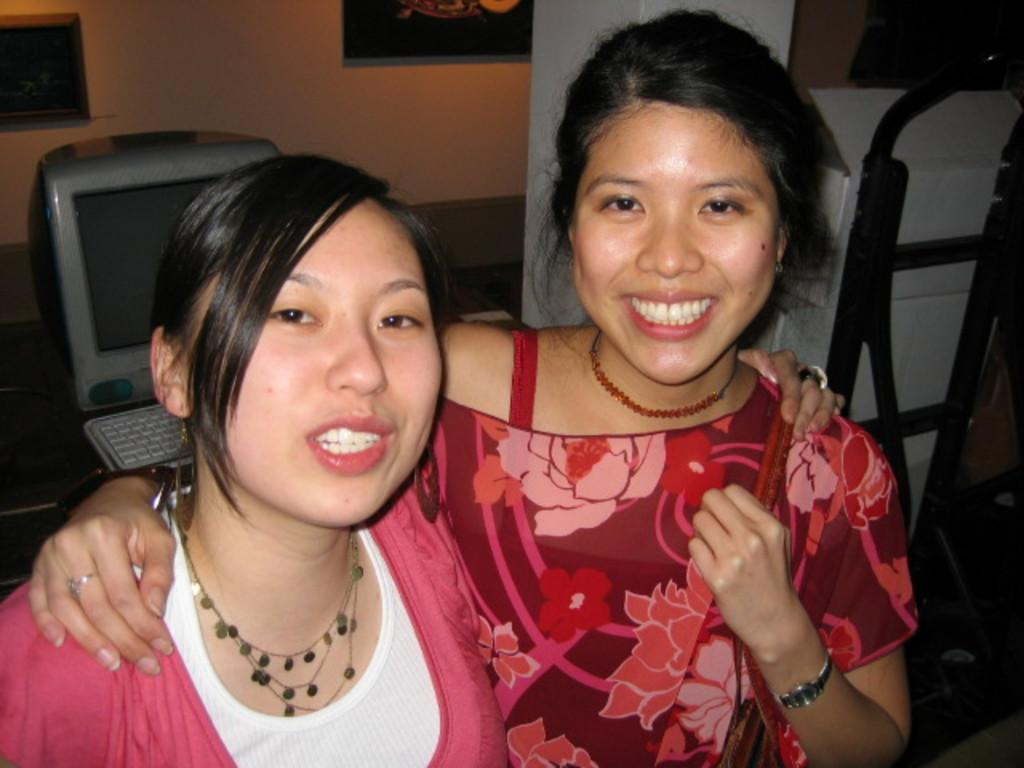How many ladies are in the image? There are two ladies in the image. What are the ladies doing in the image? The ladies are looking at something and smiling. What are the ladies wearing that is mentioned in the facts? The ladies are wearing chains. What can be seen in the background of the image? There is a wall, pillars, a monitor, a keyboard, and rods in the background of the image. What type of wax is being used by the ladies in the image? There is no mention of wax or any wax-related activity in the image. 